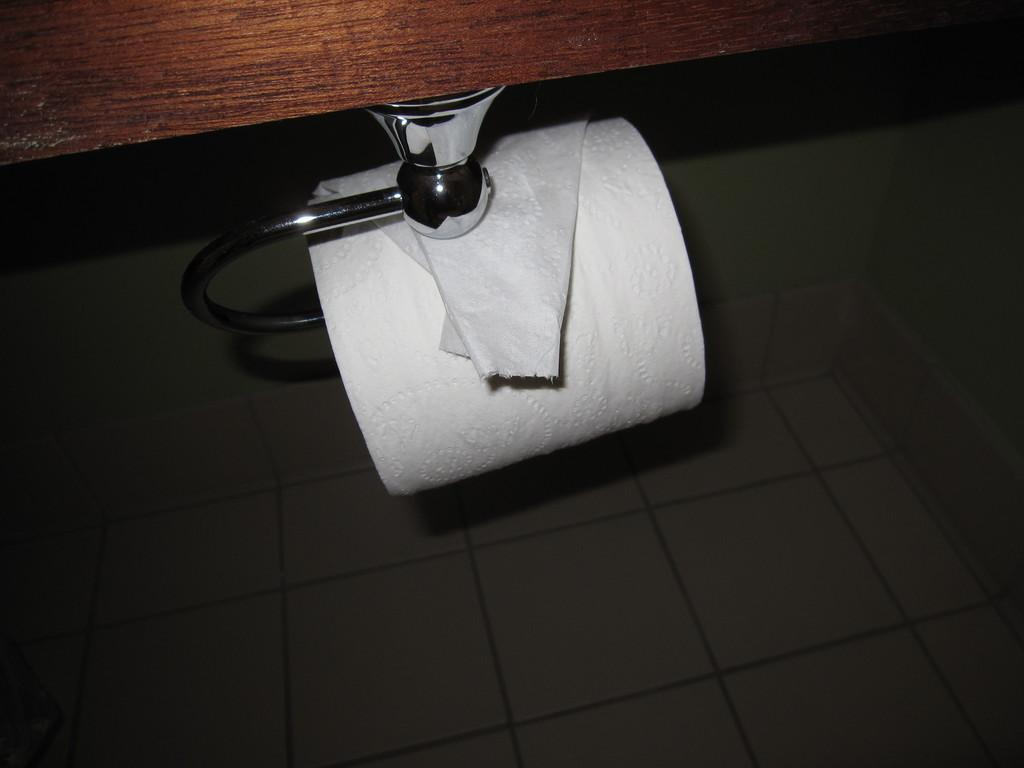What is hanging in the center of the image? There is a tissue coil on a hanger in the center of the image. What type of material is the wooden object made of? The wooden object at the top of the image is made of wood. What can be seen at the bottom of the image? The bottom of the image shows the floor. How many friends are visible in the wilderness in the image? There are no friends or wilderness present in the image. 